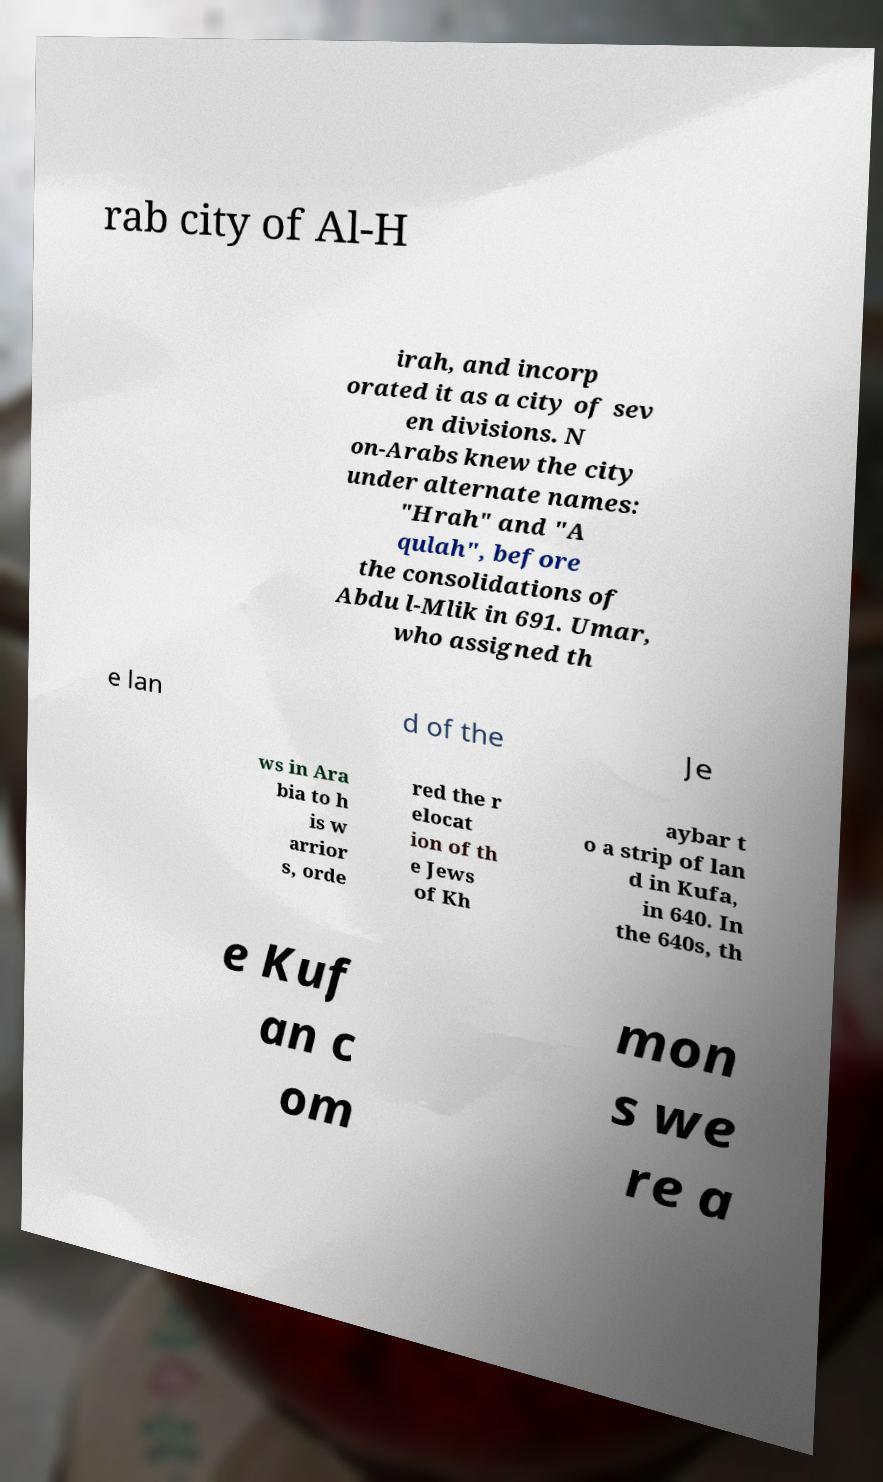Please identify and transcribe the text found in this image. rab city of Al-H irah, and incorp orated it as a city of sev en divisions. N on-Arabs knew the city under alternate names: "Hrah" and "A qulah", before the consolidations of Abdu l-Mlik in 691. Umar, who assigned th e lan d of the Je ws in Ara bia to h is w arrior s, orde red the r elocat ion of th e Jews of Kh aybar t o a strip of lan d in Kufa, in 640. In the 640s, th e Kuf an c om mon s we re a 